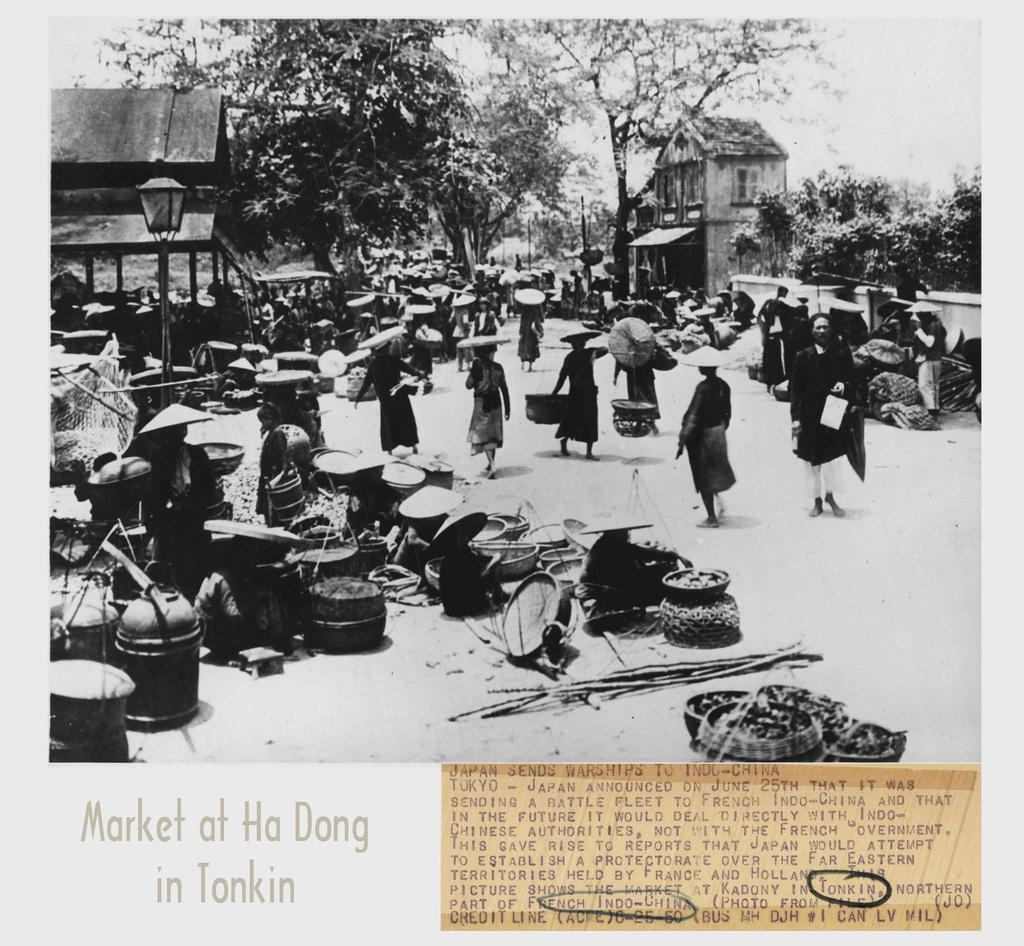<image>
Describe the image concisely. A picture in black and white of the Market at Ha Dong in Tonkin with a newspaper article next to it. 